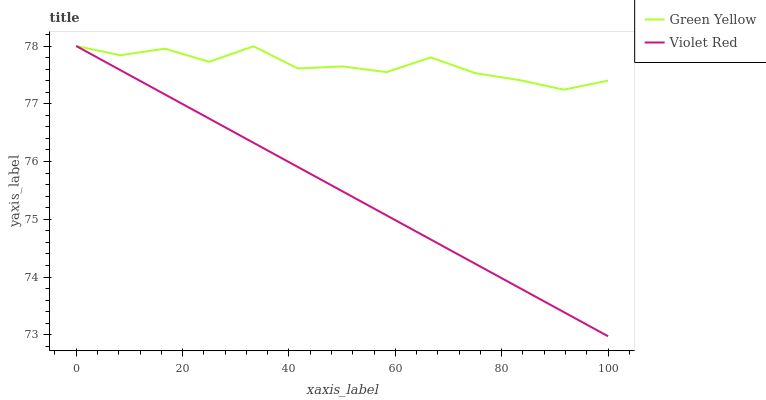Does Violet Red have the minimum area under the curve?
Answer yes or no. Yes. Does Green Yellow have the maximum area under the curve?
Answer yes or no. Yes. Does Green Yellow have the minimum area under the curve?
Answer yes or no. No. Is Violet Red the smoothest?
Answer yes or no. Yes. Is Green Yellow the roughest?
Answer yes or no. Yes. Is Green Yellow the smoothest?
Answer yes or no. No. Does Violet Red have the lowest value?
Answer yes or no. Yes. Does Green Yellow have the lowest value?
Answer yes or no. No. Does Green Yellow have the highest value?
Answer yes or no. Yes. Does Green Yellow intersect Violet Red?
Answer yes or no. Yes. Is Green Yellow less than Violet Red?
Answer yes or no. No. Is Green Yellow greater than Violet Red?
Answer yes or no. No. 